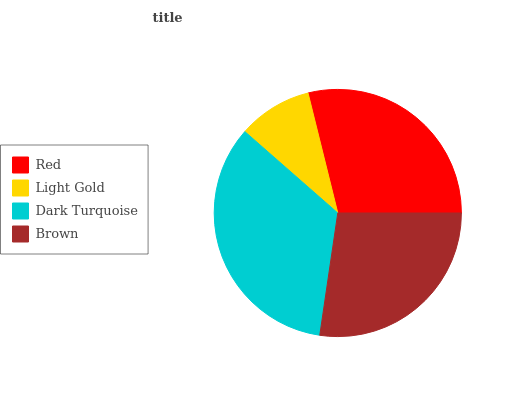Is Light Gold the minimum?
Answer yes or no. Yes. Is Dark Turquoise the maximum?
Answer yes or no. Yes. Is Dark Turquoise the minimum?
Answer yes or no. No. Is Light Gold the maximum?
Answer yes or no. No. Is Dark Turquoise greater than Light Gold?
Answer yes or no. Yes. Is Light Gold less than Dark Turquoise?
Answer yes or no. Yes. Is Light Gold greater than Dark Turquoise?
Answer yes or no. No. Is Dark Turquoise less than Light Gold?
Answer yes or no. No. Is Red the high median?
Answer yes or no. Yes. Is Brown the low median?
Answer yes or no. Yes. Is Brown the high median?
Answer yes or no. No. Is Dark Turquoise the low median?
Answer yes or no. No. 